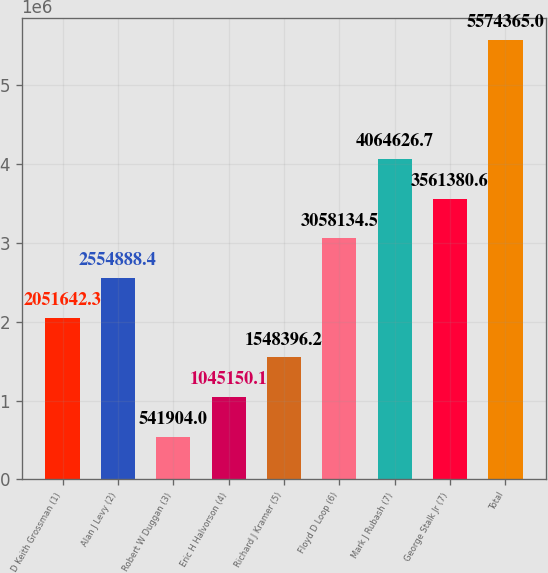Convert chart. <chart><loc_0><loc_0><loc_500><loc_500><bar_chart><fcel>D Keith Grossman (1)<fcel>Alan J Levy (2)<fcel>Robert W Duggan (3)<fcel>Eric H Halvorson (4)<fcel>Richard J Kramer (5)<fcel>Floyd D Loop (6)<fcel>Mark J Rubash (7)<fcel>George Stalk Jr (7)<fcel>Total<nl><fcel>2.05164e+06<fcel>2.55489e+06<fcel>541904<fcel>1.04515e+06<fcel>1.5484e+06<fcel>3.05813e+06<fcel>4.06463e+06<fcel>3.56138e+06<fcel>5.57436e+06<nl></chart> 